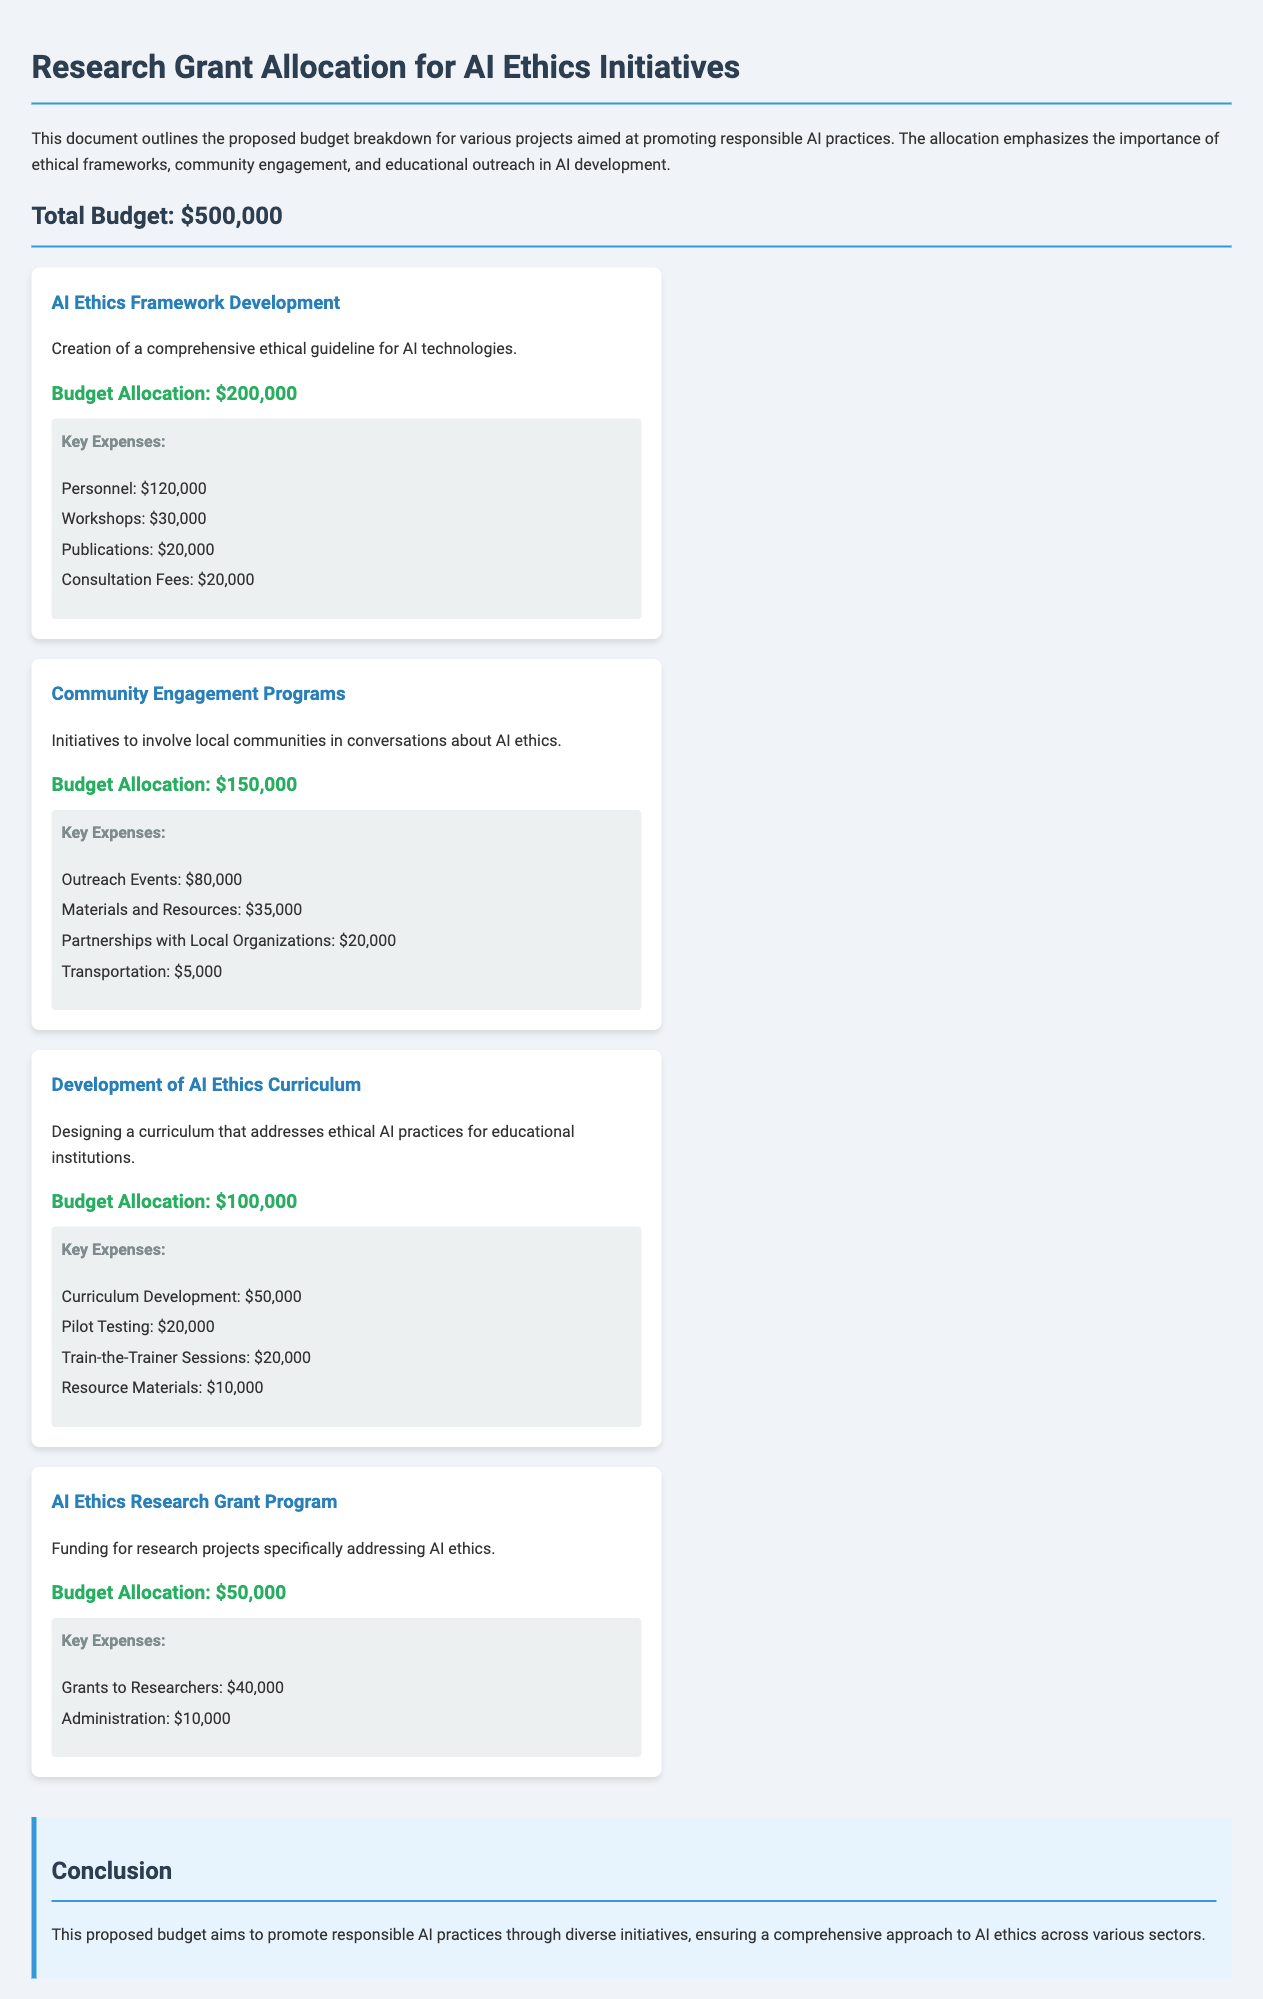What is the total budget? The total budget is explicitly stated at the beginning of the document.
Answer: $500,000 How much is allocated for AI Ethics Framework Development? The budget allocation for AI Ethics Framework Development is specified in the document.
Answer: $200,000 What is the budget for Community Engagement Programs? The document provides a specific budget allocation for this project.
Answer: $150,000 What are the key expenses for the AI Ethics Curriculum? The document lists the key expenses for this initiative, detailing various costs.
Answer: Curriculum Development, Pilot Testing, Train-the-Trainer Sessions, Resource Materials What is the amount designated for grants to researchers under the AI Ethics Research Grant Program? The document specifies how much is allocated for grants to researchers.
Answer: $40,000 What is the total budget for the Development of AI Ethics Curriculum? The total budget for this program is clearly mentioned in the document.
Answer: $100,000 Which project has the highest budget allocation? By evaluating the budget allocations given in the document, it can be determined which project has the highest funding.
Answer: AI Ethics Framework Development What is the amount set aside for personnel in the AI Ethics Framework Development? The document details key expenses, including how much is allocated for personnel.
Answer: $120,000 How much budget is allocated for Outreach Events in the Community Engagement Programs? The specific budget for Outreach Events is listed in the document under the key expenses.
Answer: $80,000 